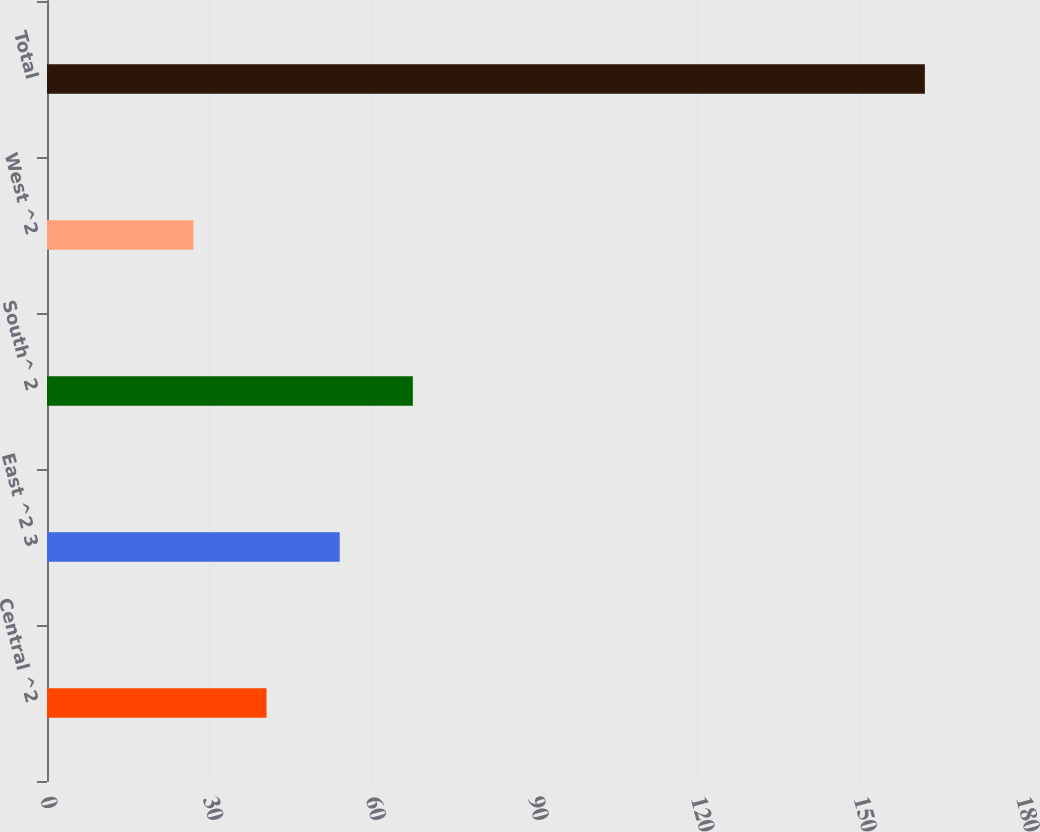Convert chart. <chart><loc_0><loc_0><loc_500><loc_500><bar_chart><fcel>Central ^2<fcel>East ^2 3<fcel>South^ 2<fcel>West ^2<fcel>Total<nl><fcel>40.49<fcel>53.98<fcel>67.47<fcel>27<fcel>161.9<nl></chart> 